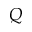<formula> <loc_0><loc_0><loc_500><loc_500>Q</formula> 